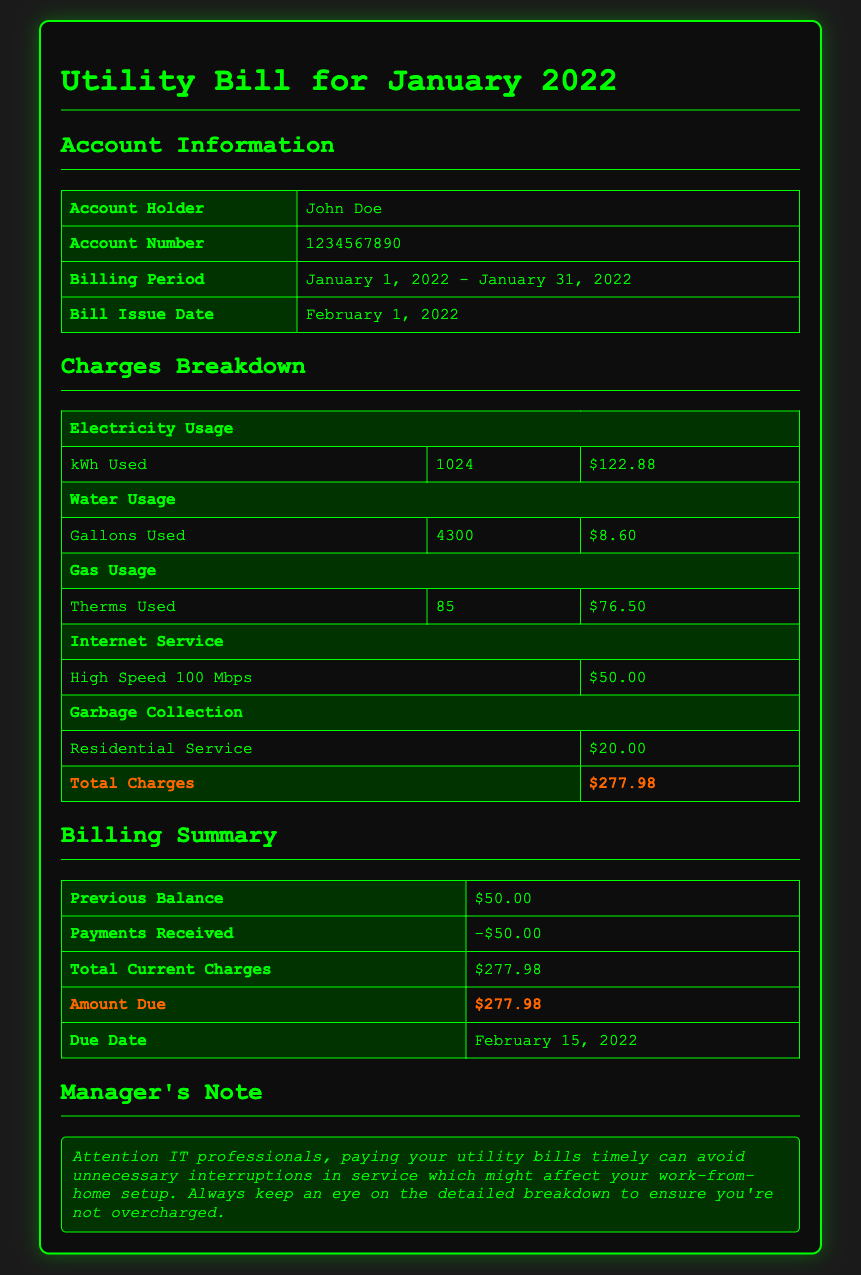What is the account holder's name? The account holder's name is found in the Account Information section of the document.
Answer: John Doe What is the total charges amount? The total charges amount is at the end of the Charges Breakdown table.
Answer: $277.98 When was the bill issued? The bill issue date can be found in the Account Information section.
Answer: February 1, 2022 How many gallons of water were used? The water usage can be found in the Charges Breakdown section.
Answer: 4300 What is the due date for the payment? The due date is located in the Billing Summary section of the document.
Answer: February 15, 2022 What was the previous balance? The previous balance is stated in the Billing Summary section.
Answer: $50.00 What is the charge for high-speed internet service? The charge for internet service is in the Charges Breakdown table.
Answer: $50.00 What type of service is garbage collection listed as? The type of garbage collection service is given in the Charges Breakdown section.
Answer: Residential Service 